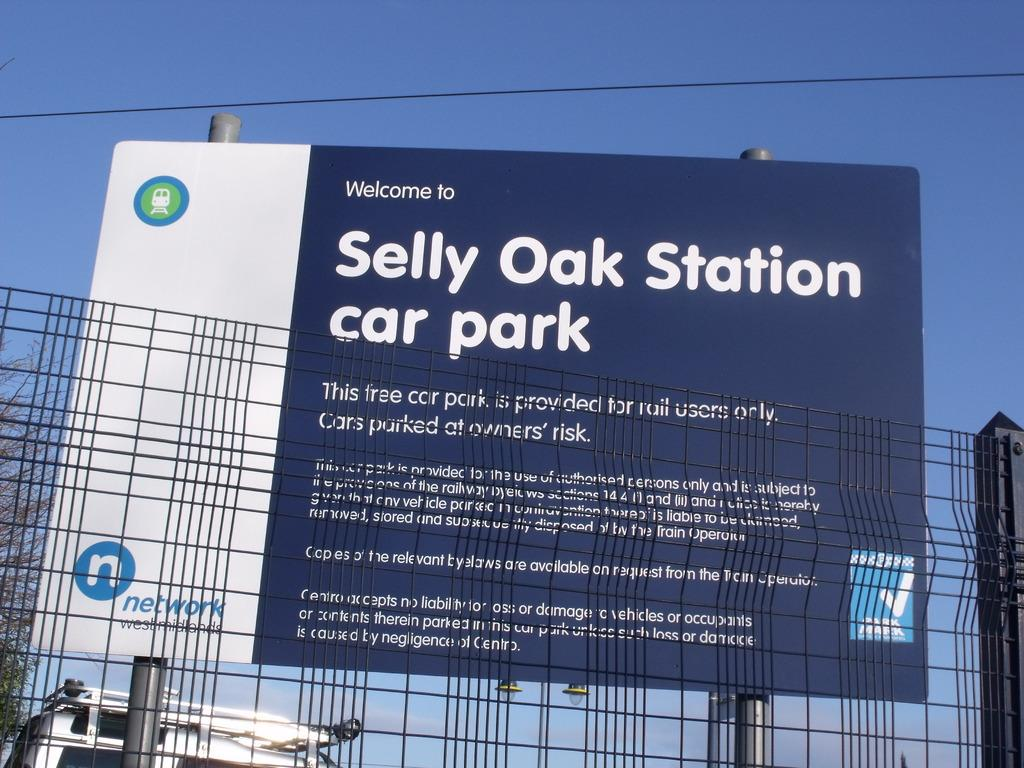<image>
Provide a brief description of the given image. A large sign welcomes you to Selly Oak Station car park. 